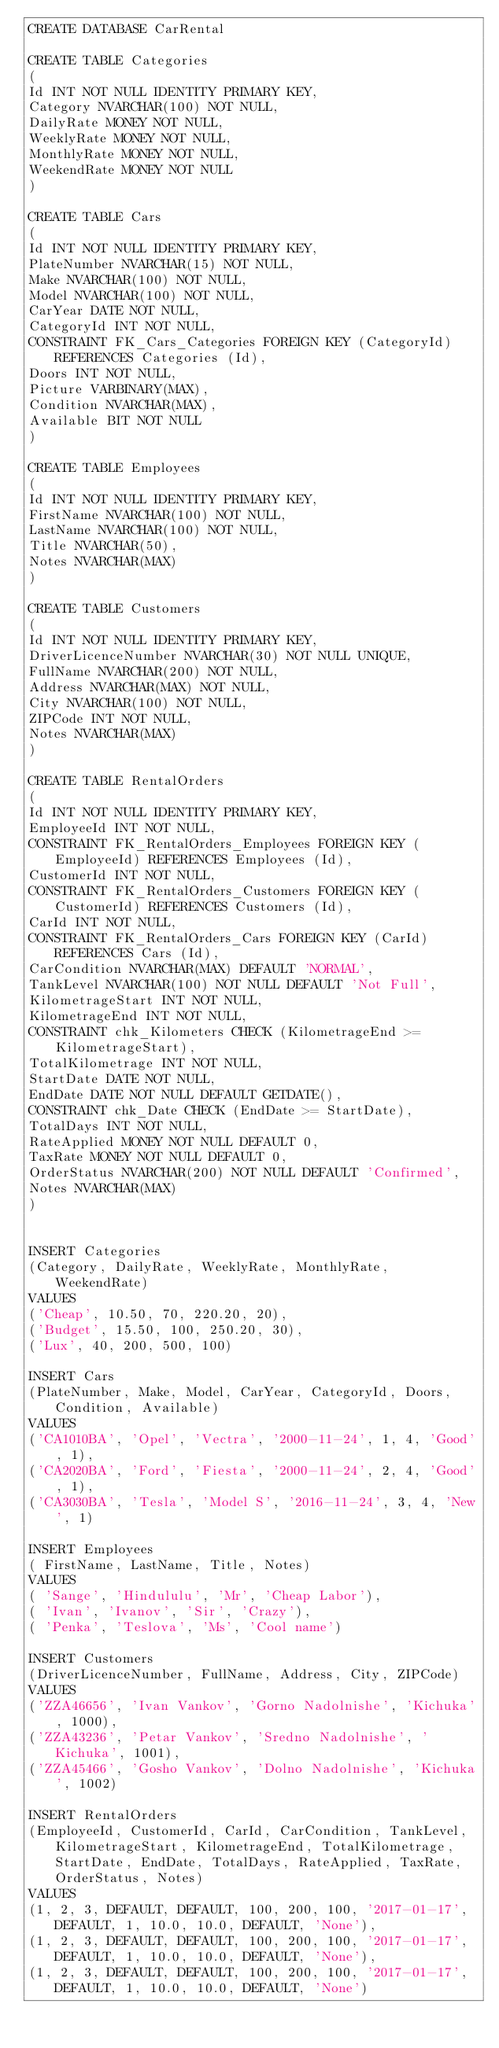<code> <loc_0><loc_0><loc_500><loc_500><_SQL_>CREATE DATABASE CarRental

CREATE TABLE Categories
(
Id INT NOT NULL IDENTITY PRIMARY KEY,
Category NVARCHAR(100) NOT NULL,
DailyRate MONEY NOT NULL,
WeeklyRate MONEY NOT NULL,
MonthlyRate MONEY NOT NULL,
WeekendRate MONEY NOT NULL
)

CREATE TABLE Cars
(
Id INT NOT NULL IDENTITY PRIMARY KEY,
PlateNumber NVARCHAR(15) NOT NULL,
Make NVARCHAR(100) NOT NULL,
Model NVARCHAR(100) NOT NULL,
CarYear DATE NOT NULL,
CategoryId INT NOT NULL,
CONSTRAINT FK_Cars_Categories FOREIGN KEY (CategoryId) REFERENCES Categories (Id),
Doors INT NOT NULL,
Picture VARBINARY(MAX),
Condition NVARCHAR(MAX),
Available BIT NOT NULL
)

CREATE TABLE Employees
(
Id INT NOT NULL IDENTITY PRIMARY KEY,
FirstName NVARCHAR(100) NOT NULL,
LastName NVARCHAR(100) NOT NULL,
Title NVARCHAR(50),
Notes NVARCHAR(MAX)
)

CREATE TABLE Customers
(
Id INT NOT NULL IDENTITY PRIMARY KEY,
DriverLicenceNumber NVARCHAR(30) NOT NULL UNIQUE,
FullName NVARCHAR(200) NOT NULL,
Address NVARCHAR(MAX) NOT NULL,
City NVARCHAR(100) NOT NULL,
ZIPCode INT NOT NULL,
Notes NVARCHAR(MAX)
)

CREATE TABLE RentalOrders
(
Id INT NOT NULL IDENTITY PRIMARY KEY,
EmployeeId INT NOT NULL,
CONSTRAINT FK_RentalOrders_Employees FOREIGN KEY (EmployeeId) REFERENCES Employees (Id),
CustomerId INT NOT NULL,
CONSTRAINT FK_RentalOrders_Customers FOREIGN KEY (CustomerId) REFERENCES Customers (Id),
CarId INT NOT NULL,
CONSTRAINT FK_RentalOrders_Cars FOREIGN KEY (CarId) REFERENCES Cars (Id),
CarCondition NVARCHAR(MAX) DEFAULT 'NORMAL',
TankLevel NVARCHAR(100) NOT NULL DEFAULT 'Not Full',
KilometrageStart INT NOT NULL,
KilometrageEnd INT NOT NULL,
CONSTRAINT chk_Kilometers CHECK (KilometrageEnd >= KilometrageStart),
TotalKilometrage INT NOT NULL,
StartDate DATE NOT NULL,
EndDate DATE NOT NULL DEFAULT GETDATE(),
CONSTRAINT chk_Date CHECK (EndDate >= StartDate),
TotalDays INT NOT NULL,
RateApplied MONEY NOT NULL DEFAULT 0,
TaxRate MONEY NOT NULL DEFAULT 0,
OrderStatus NVARCHAR(200) NOT NULL DEFAULT 'Confirmed',
Notes NVARCHAR(MAX)
)


INSERT Categories
(Category, DailyRate, WeeklyRate, MonthlyRate, WeekendRate)
VALUES
('Cheap', 10.50, 70, 220.20, 20),
('Budget', 15.50, 100, 250.20, 30),
('Lux', 40, 200, 500, 100)

INSERT Cars
(PlateNumber, Make, Model, CarYear, CategoryId, Doors, Condition, Available)
VALUES
('CA1010BA', 'Opel', 'Vectra', '2000-11-24', 1, 4, 'Good', 1),
('CA2020BA', 'Ford', 'Fiesta', '2000-11-24', 2, 4, 'Good', 1),
('CA3030BA', 'Tesla', 'Model S', '2016-11-24', 3, 4, 'New', 1)

INSERT Employees
( FirstName, LastName, Title, Notes)
VALUES
( 'Sange', 'Hindululu', 'Mr', 'Cheap Labor'),
( 'Ivan', 'Ivanov', 'Sir', 'Crazy'),
( 'Penka', 'Teslova', 'Ms', 'Cool name')

INSERT Customers
(DriverLicenceNumber, FullName, Address, City, ZIPCode)
VALUES
('ZZA46656', 'Ivan Vankov', 'Gorno Nadolnishe', 'Kichuka', 1000),
('ZZA43236', 'Petar Vankov', 'Sredno Nadolnishe', 'Kichuka', 1001),
('ZZA45466', 'Gosho Vankov', 'Dolno Nadolnishe', 'Kichuka', 1002)

INSERT RentalOrders
(EmployeeId, CustomerId, CarId, CarCondition, TankLevel, KilometrageStart, KilometrageEnd, TotalKilometrage, StartDate, EndDate, TotalDays, RateApplied, TaxRate, OrderStatus, Notes)
VALUES
(1, 2, 3, DEFAULT, DEFAULT, 100, 200, 100, '2017-01-17', DEFAULT, 1, 10.0, 10.0, DEFAULT, 'None'),
(1, 2, 3, DEFAULT, DEFAULT, 100, 200, 100, '2017-01-17', DEFAULT, 1, 10.0, 10.0, DEFAULT, 'None'),
(1, 2, 3, DEFAULT, DEFAULT, 100, 200, 100, '2017-01-17', DEFAULT, 1, 10.0, 10.0, DEFAULT, 'None')</code> 